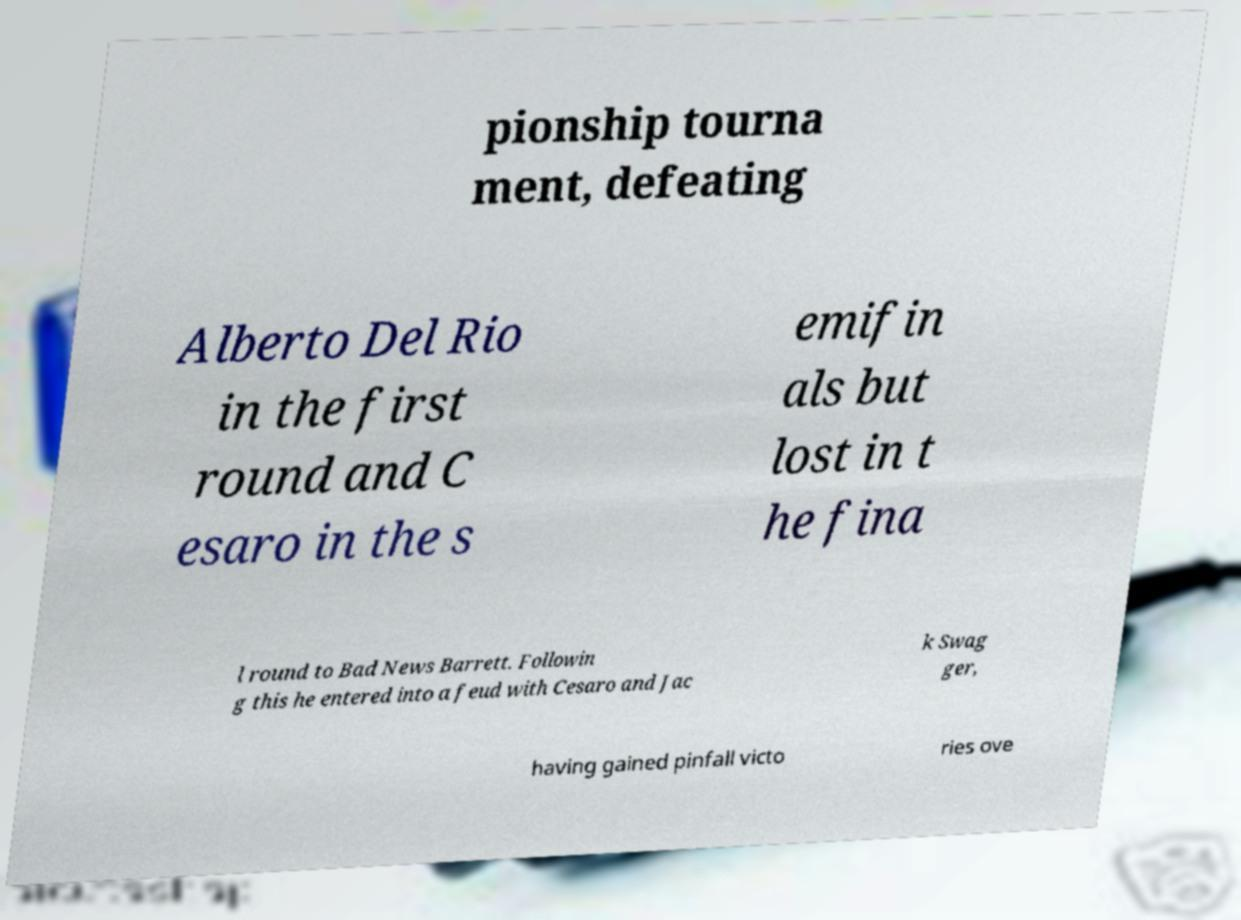For documentation purposes, I need the text within this image transcribed. Could you provide that? pionship tourna ment, defeating Alberto Del Rio in the first round and C esaro in the s emifin als but lost in t he fina l round to Bad News Barrett. Followin g this he entered into a feud with Cesaro and Jac k Swag ger, having gained pinfall victo ries ove 